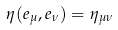<formula> <loc_0><loc_0><loc_500><loc_500>\eta ( e _ { \mu } , e _ { \nu } ) = \eta _ { \mu \nu }</formula> 